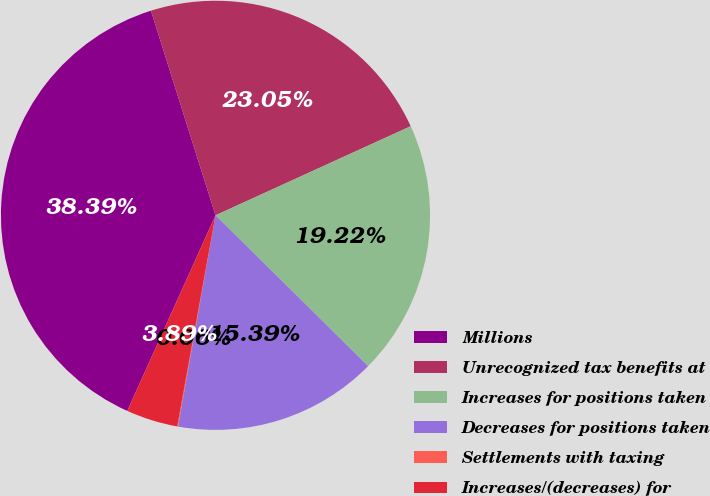Convert chart. <chart><loc_0><loc_0><loc_500><loc_500><pie_chart><fcel>Millions<fcel>Unrecognized tax benefits at<fcel>Increases for positions taken<fcel>Decreases for positions taken<fcel>Settlements with taxing<fcel>Increases/(decreases) for<nl><fcel>38.39%<fcel>23.05%<fcel>19.22%<fcel>15.39%<fcel>0.06%<fcel>3.89%<nl></chart> 